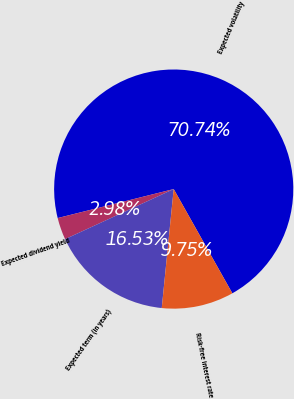Convert chart to OTSL. <chart><loc_0><loc_0><loc_500><loc_500><pie_chart><fcel>Expected volatility<fcel>Expected dividend yield<fcel>Expected term (in years)<fcel>Risk-free interest rate<nl><fcel>70.74%<fcel>2.98%<fcel>16.53%<fcel>9.75%<nl></chart> 